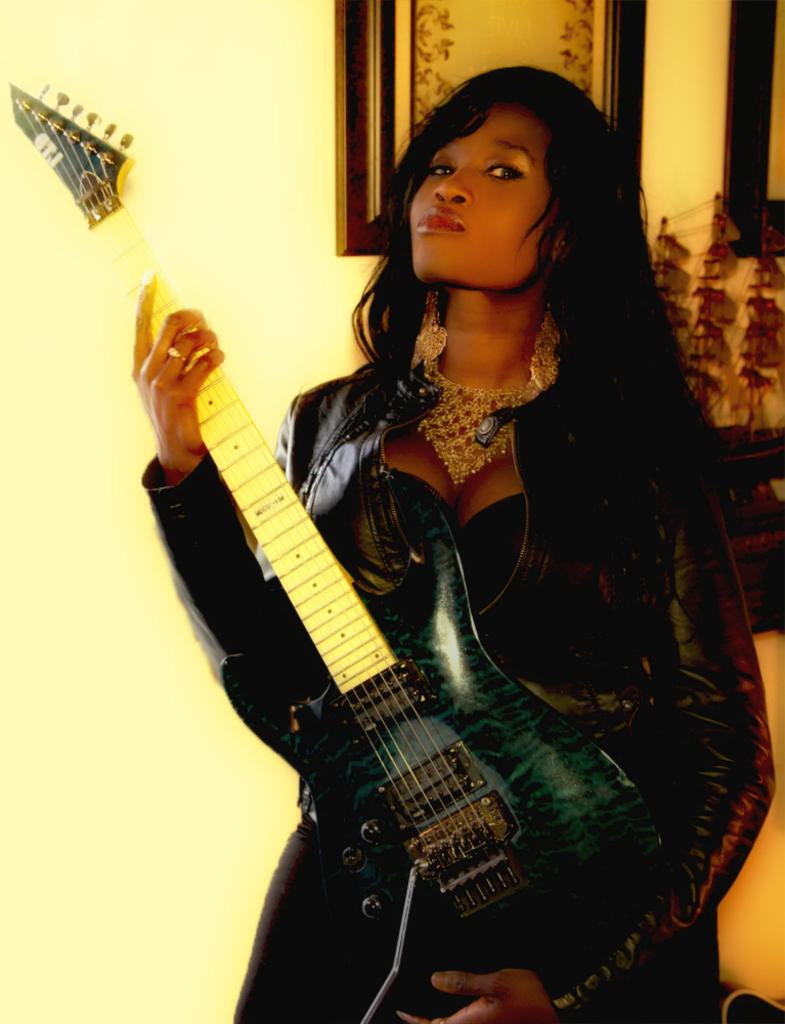Who is the main subject in the image? There is a woman in the image. What is the woman wearing? The woman is wearing a black dress. What is the woman doing in the image? The woman is standing and holding a guitar. What can be seen on the wall in the background? There are photo frames on a yellow color wall in the background, and there are items on the wall as well. What is the name of the woman in the image? The name of the woman in the image is not mentioned or visible, so it cannot be determined. 